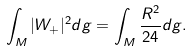<formula> <loc_0><loc_0><loc_500><loc_500>\int _ { M } | W _ { + } | ^ { 2 } d g = \int _ { M } \frac { R ^ { 2 } } { 2 4 } d g .</formula> 